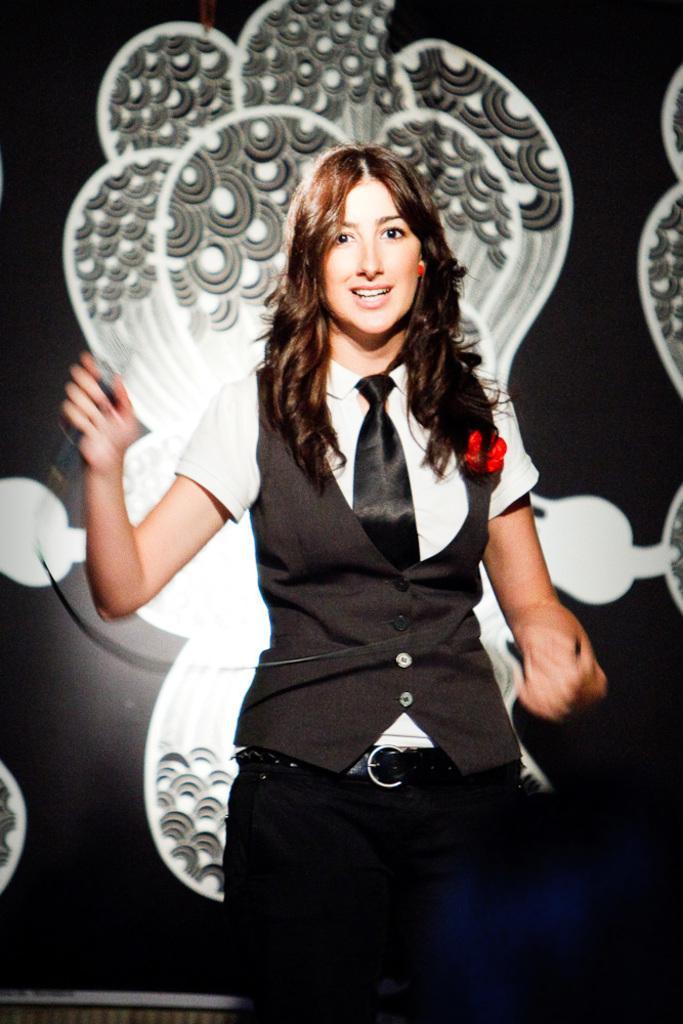Could you give a brief overview of what you see in this image? In the center of the picture there is a woman holding a mic. In the background it is well, on the wall there are designs. 